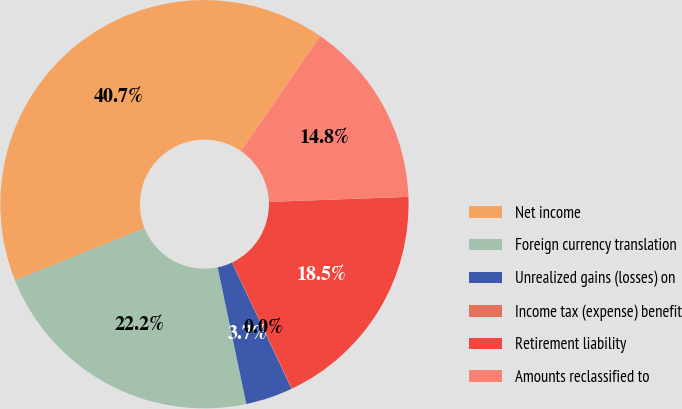Convert chart. <chart><loc_0><loc_0><loc_500><loc_500><pie_chart><fcel>Net income<fcel>Foreign currency translation<fcel>Unrealized gains (losses) on<fcel>Income tax (expense) benefit<fcel>Retirement liability<fcel>Amounts reclassified to<nl><fcel>40.7%<fcel>22.21%<fcel>3.73%<fcel>0.03%<fcel>18.52%<fcel>14.82%<nl></chart> 